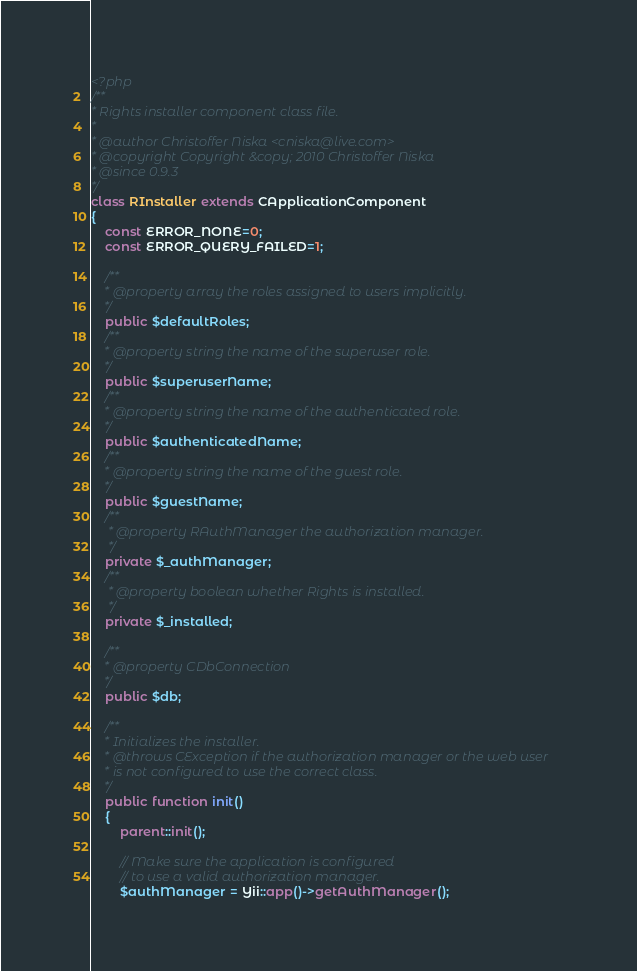Convert code to text. <code><loc_0><loc_0><loc_500><loc_500><_PHP_><?php
/**
* Rights installer component class file.
*
* @author Christoffer Niska <cniska@live.com>
* @copyright Copyright &copy; 2010 Christoffer Niska
* @since 0.9.3
*/
class RInstaller extends CApplicationComponent
{
    const ERROR_NONE=0;
    const ERROR_QUERY_FAILED=1;

	/**
	* @property array the roles assigned to users implicitly.
	*/
	public $defaultRoles;
	/**
	* @property string the name of the superuser role.
	*/
	public $superuserName;
	/**
	* @property string the name of the authenticated role.
	*/
	public $authenticatedName;
	/**
	* @property string the name of the guest role.
	*/
	public $guestName;
    /**
     * @property RAuthManager the authorization manager.
     */
	private $_authManager;
    /**
     * @property boolean whether Rights is installed.
     */
	private $_installed;

	/**
	* @property CDbConnection
	*/
	public $db;

	/**
	* Initializes the installer.
	* @throws CException if the authorization manager or the web user
	* is not configured to use the correct class.
	*/
	public function init()
	{
		parent::init();

		// Make sure the application is configured
		// to use a valid authorization manager.
		$authManager = Yii::app()->getAuthManager();</code> 